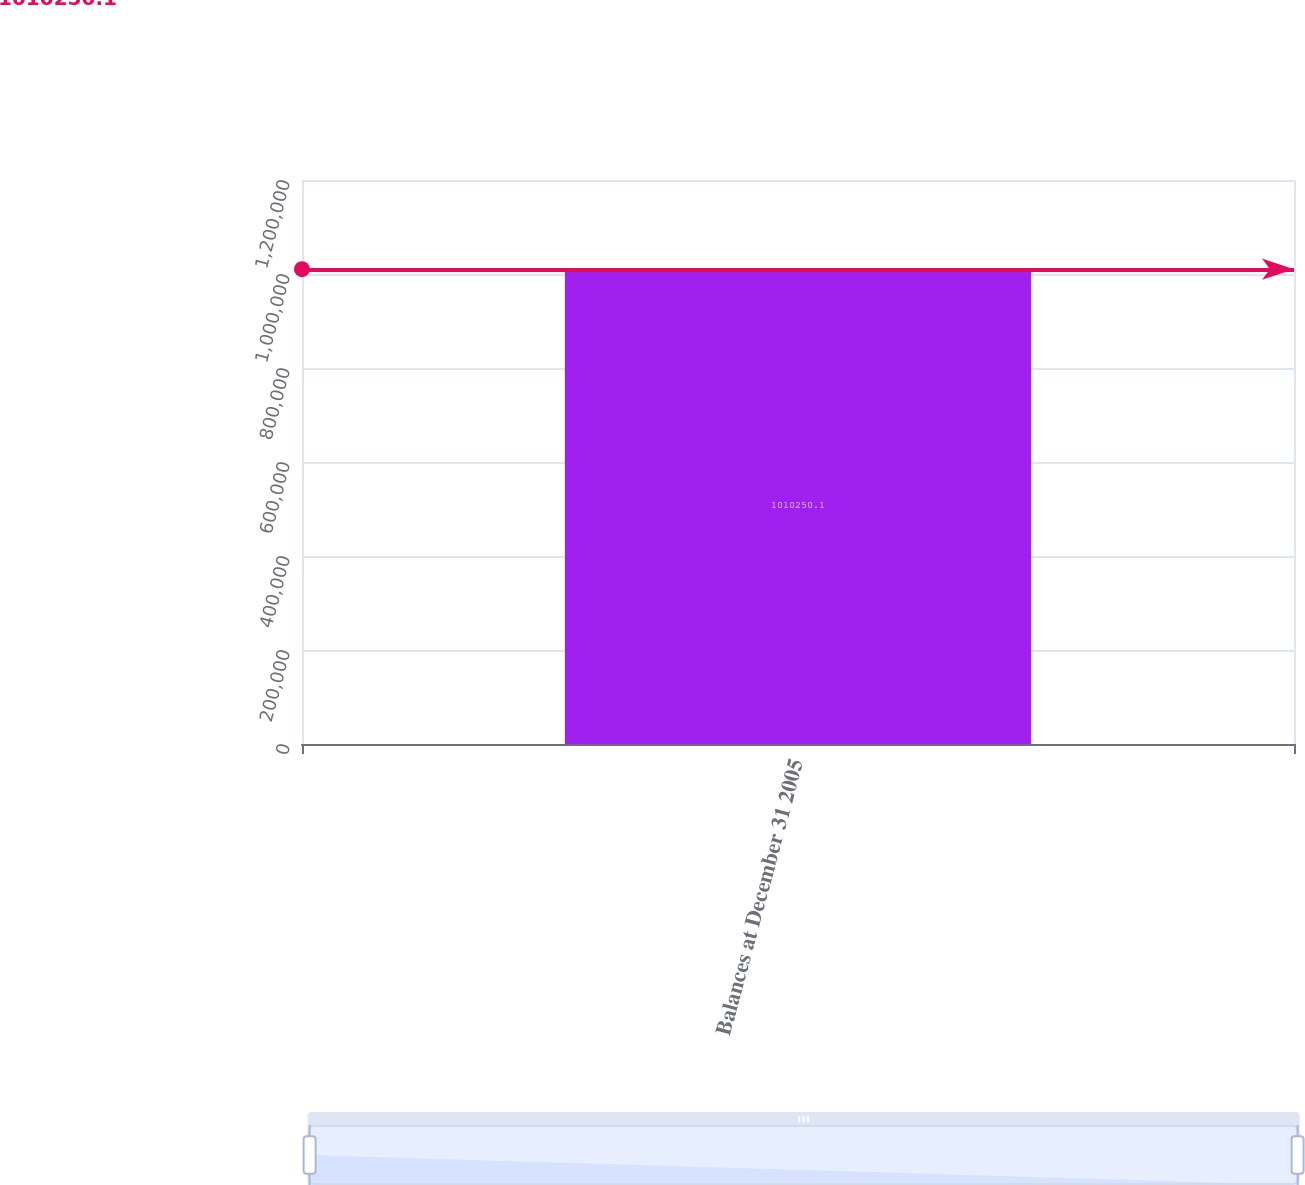Convert chart. <chart><loc_0><loc_0><loc_500><loc_500><bar_chart><fcel>Balances at December 31 2005<nl><fcel>1.01025e+06<nl></chart> 